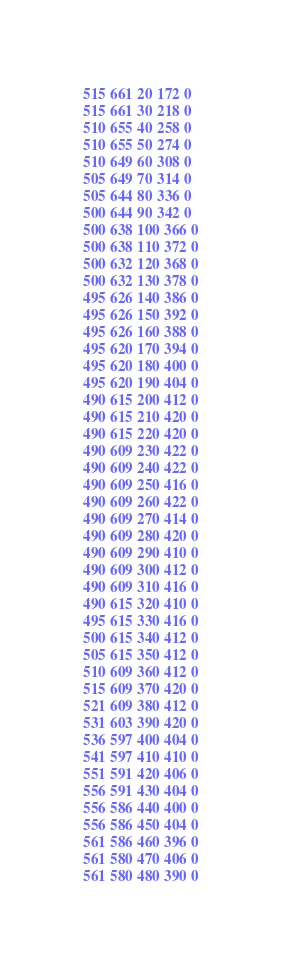Convert code to text. <code><loc_0><loc_0><loc_500><loc_500><_SML_>515 661 20 172 0
515 661 30 218 0
510 655 40 258 0
510 655 50 274 0
510 649 60 308 0
505 649 70 314 0
505 644 80 336 0
500 644 90 342 0
500 638 100 366 0
500 638 110 372 0
500 632 120 368 0
500 632 130 378 0
495 626 140 386 0
495 626 150 392 0
495 626 160 388 0
495 620 170 394 0
495 620 180 400 0
495 620 190 404 0
490 615 200 412 0
490 615 210 420 0
490 615 220 420 0
490 609 230 422 0
490 609 240 422 0
490 609 250 416 0
490 609 260 422 0
490 609 270 414 0
490 609 280 420 0
490 609 290 410 0
490 609 300 412 0
490 609 310 416 0
490 615 320 410 0
495 615 330 416 0
500 615 340 412 0
505 615 350 412 0
510 609 360 412 0
515 609 370 420 0
521 609 380 412 0
531 603 390 420 0
536 597 400 404 0
541 597 410 410 0
551 591 420 406 0
556 591 430 404 0
556 586 440 400 0
556 586 450 404 0
561 586 460 396 0
561 580 470 406 0
561 580 480 390 0</code> 